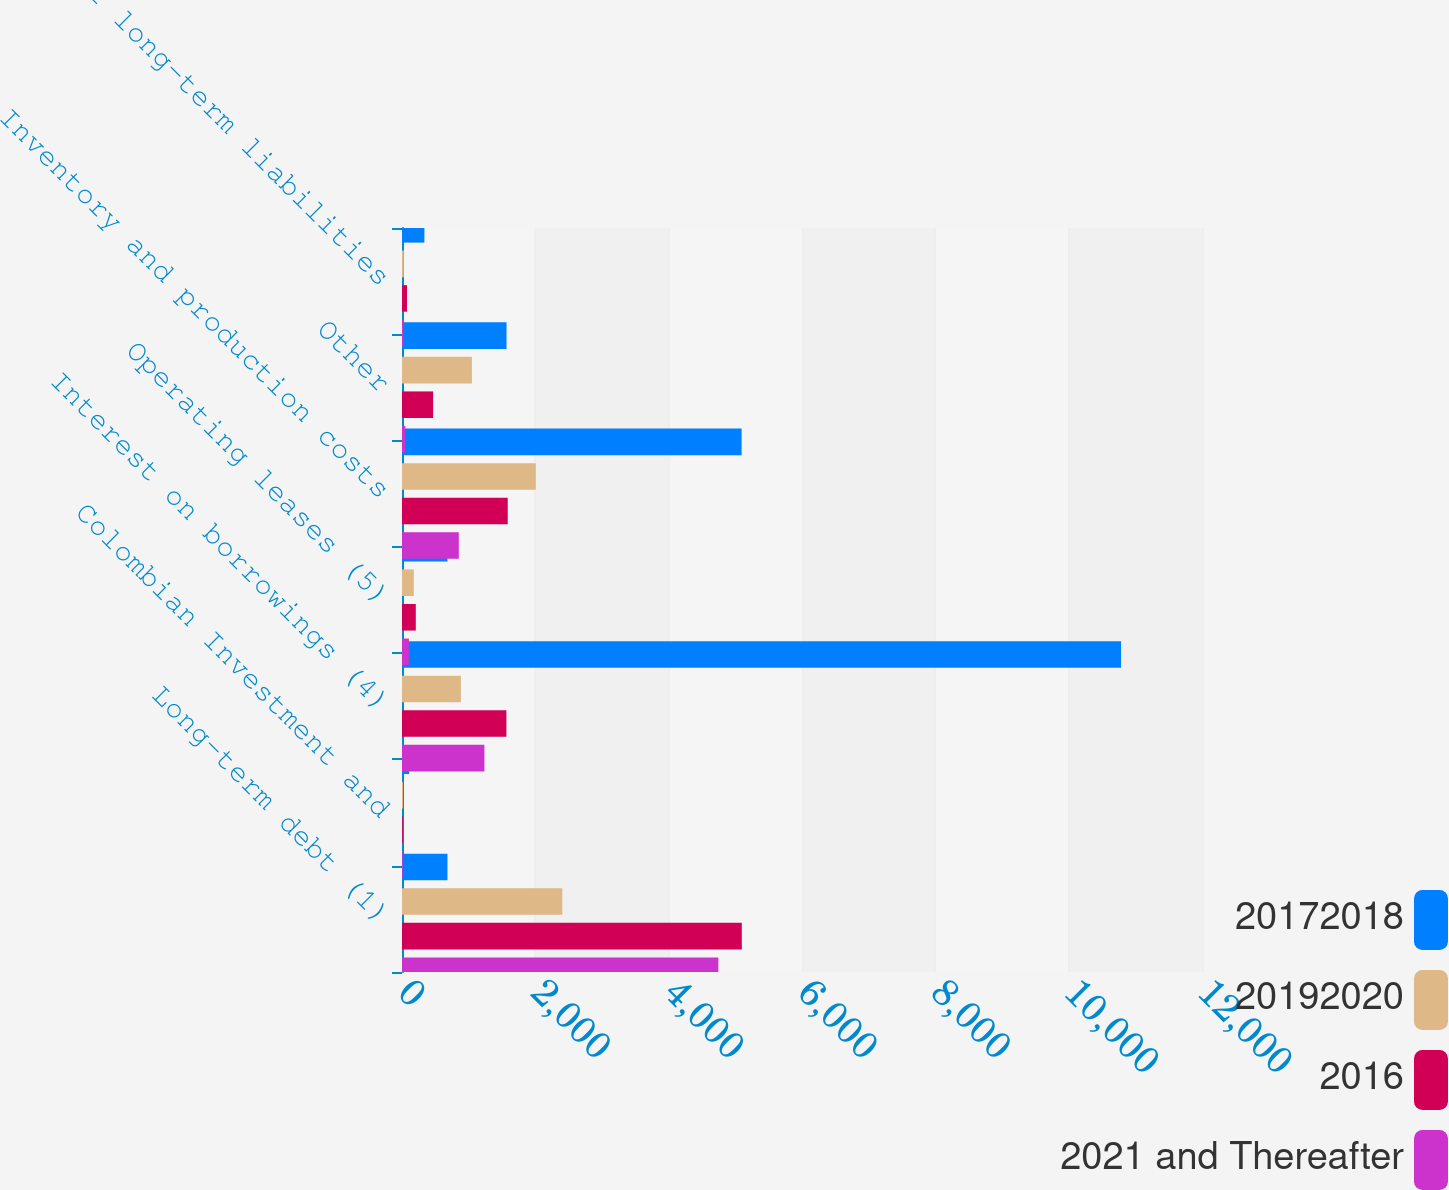<chart> <loc_0><loc_0><loc_500><loc_500><stacked_bar_chart><ecel><fcel>Long-term debt (1)<fcel>Colombian Investment and<fcel>Interest on borrowings (4)<fcel>Operating leases (5)<fcel>Inventory and production costs<fcel>Other<fcel>Other long-term liabilities<nl><fcel>20172018<fcel>682<fcel>107<fcel>10786<fcel>682<fcel>5094<fcel>1568<fcel>336<nl><fcel>20192020<fcel>2405<fcel>15<fcel>883<fcel>177<fcel>2007<fcel>1049<fcel>27<nl><fcel>2016<fcel>5097<fcel>12<fcel>1566<fcel>207<fcel>1586<fcel>467<fcel>75<nl><fcel>2021 and Thereafter<fcel>4745<fcel>12<fcel>1236<fcel>103<fcel>852<fcel>50<fcel>25<nl></chart> 